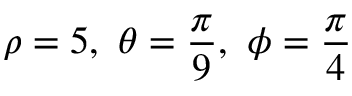Convert formula to latex. <formula><loc_0><loc_0><loc_500><loc_500>\rho = 5 , \ \theta = { \frac { \pi } { 9 } } , \ \phi = { \frac { \pi } { 4 } }</formula> 